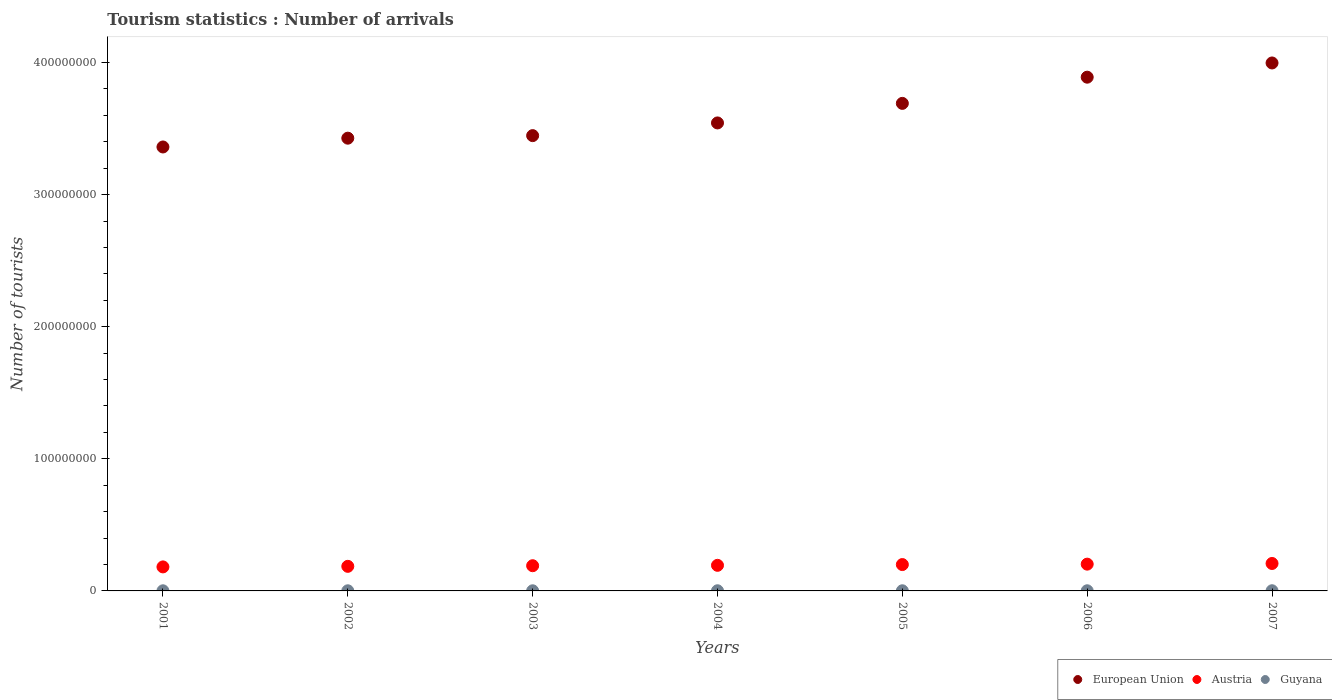What is the number of tourist arrivals in European Union in 2003?
Offer a terse response. 3.45e+08. Across all years, what is the maximum number of tourist arrivals in Guyana?
Keep it short and to the point. 1.34e+05. Across all years, what is the minimum number of tourist arrivals in Guyana?
Offer a very short reply. 9.90e+04. In which year was the number of tourist arrivals in European Union maximum?
Make the answer very short. 2007. What is the total number of tourist arrivals in Guyana in the graph?
Make the answer very short. 7.90e+05. What is the difference between the number of tourist arrivals in European Union in 2002 and that in 2005?
Make the answer very short. -2.63e+07. What is the difference between the number of tourist arrivals in Guyana in 2004 and the number of tourist arrivals in European Union in 2003?
Ensure brevity in your answer.  -3.45e+08. What is the average number of tourist arrivals in Guyana per year?
Keep it short and to the point. 1.13e+05. In the year 2004, what is the difference between the number of tourist arrivals in European Union and number of tourist arrivals in Guyana?
Offer a very short reply. 3.54e+08. What is the ratio of the number of tourist arrivals in Austria in 2002 to that in 2003?
Make the answer very short. 0.98. What is the difference between the highest and the second highest number of tourist arrivals in Austria?
Give a very brief answer. 5.04e+05. What is the difference between the highest and the lowest number of tourist arrivals in Guyana?
Make the answer very short. 3.50e+04. Is the sum of the number of tourist arrivals in European Union in 2001 and 2004 greater than the maximum number of tourist arrivals in Austria across all years?
Ensure brevity in your answer.  Yes. Does the number of tourist arrivals in European Union monotonically increase over the years?
Provide a succinct answer. Yes. Is the number of tourist arrivals in Austria strictly greater than the number of tourist arrivals in Guyana over the years?
Make the answer very short. Yes. Is the number of tourist arrivals in Austria strictly less than the number of tourist arrivals in Guyana over the years?
Your response must be concise. No. How many dotlines are there?
Ensure brevity in your answer.  3. How many years are there in the graph?
Offer a terse response. 7. Are the values on the major ticks of Y-axis written in scientific E-notation?
Give a very brief answer. No. Does the graph contain grids?
Offer a terse response. No. Where does the legend appear in the graph?
Your response must be concise. Bottom right. How are the legend labels stacked?
Your answer should be very brief. Horizontal. What is the title of the graph?
Give a very brief answer. Tourism statistics : Number of arrivals. Does "Bangladesh" appear as one of the legend labels in the graph?
Your response must be concise. No. What is the label or title of the Y-axis?
Offer a terse response. Number of tourists. What is the Number of tourists in European Union in 2001?
Provide a short and direct response. 3.36e+08. What is the Number of tourists of Austria in 2001?
Your answer should be compact. 1.82e+07. What is the Number of tourists in Guyana in 2001?
Provide a succinct answer. 9.90e+04. What is the Number of tourists of European Union in 2002?
Your response must be concise. 3.43e+08. What is the Number of tourists in Austria in 2002?
Ensure brevity in your answer.  1.86e+07. What is the Number of tourists in Guyana in 2002?
Make the answer very short. 1.04e+05. What is the Number of tourists of European Union in 2003?
Your answer should be compact. 3.45e+08. What is the Number of tourists of Austria in 2003?
Your response must be concise. 1.91e+07. What is the Number of tourists in Guyana in 2003?
Provide a short and direct response. 1.01e+05. What is the Number of tourists in European Union in 2004?
Keep it short and to the point. 3.54e+08. What is the Number of tourists of Austria in 2004?
Offer a very short reply. 1.94e+07. What is the Number of tourists of Guyana in 2004?
Your response must be concise. 1.22e+05. What is the Number of tourists of European Union in 2005?
Provide a succinct answer. 3.69e+08. What is the Number of tourists of Austria in 2005?
Offer a terse response. 2.00e+07. What is the Number of tourists of Guyana in 2005?
Provide a succinct answer. 1.17e+05. What is the Number of tourists of European Union in 2006?
Provide a succinct answer. 3.89e+08. What is the Number of tourists of Austria in 2006?
Your answer should be compact. 2.03e+07. What is the Number of tourists in Guyana in 2006?
Offer a terse response. 1.13e+05. What is the Number of tourists of European Union in 2007?
Give a very brief answer. 4.00e+08. What is the Number of tourists in Austria in 2007?
Offer a very short reply. 2.08e+07. What is the Number of tourists in Guyana in 2007?
Your answer should be compact. 1.34e+05. Across all years, what is the maximum Number of tourists of European Union?
Offer a very short reply. 4.00e+08. Across all years, what is the maximum Number of tourists of Austria?
Your answer should be very brief. 2.08e+07. Across all years, what is the maximum Number of tourists of Guyana?
Offer a very short reply. 1.34e+05. Across all years, what is the minimum Number of tourists of European Union?
Make the answer very short. 3.36e+08. Across all years, what is the minimum Number of tourists in Austria?
Ensure brevity in your answer.  1.82e+07. Across all years, what is the minimum Number of tourists of Guyana?
Provide a succinct answer. 9.90e+04. What is the total Number of tourists of European Union in the graph?
Provide a succinct answer. 2.54e+09. What is the total Number of tourists in Austria in the graph?
Give a very brief answer. 1.36e+08. What is the total Number of tourists of Guyana in the graph?
Offer a terse response. 7.90e+05. What is the difference between the Number of tourists of European Union in 2001 and that in 2002?
Offer a very short reply. -6.65e+06. What is the difference between the Number of tourists in Austria in 2001 and that in 2002?
Make the answer very short. -4.31e+05. What is the difference between the Number of tourists of Guyana in 2001 and that in 2002?
Your answer should be very brief. -5000. What is the difference between the Number of tourists of European Union in 2001 and that in 2003?
Offer a terse response. -8.59e+06. What is the difference between the Number of tourists of Austria in 2001 and that in 2003?
Your answer should be very brief. -8.98e+05. What is the difference between the Number of tourists in Guyana in 2001 and that in 2003?
Offer a very short reply. -2000. What is the difference between the Number of tourists of European Union in 2001 and that in 2004?
Your answer should be compact. -1.82e+07. What is the difference between the Number of tourists of Austria in 2001 and that in 2004?
Offer a terse response. -1.19e+06. What is the difference between the Number of tourists in Guyana in 2001 and that in 2004?
Provide a short and direct response. -2.30e+04. What is the difference between the Number of tourists in European Union in 2001 and that in 2005?
Your response must be concise. -3.30e+07. What is the difference between the Number of tourists of Austria in 2001 and that in 2005?
Offer a very short reply. -1.77e+06. What is the difference between the Number of tourists in Guyana in 2001 and that in 2005?
Provide a short and direct response. -1.80e+04. What is the difference between the Number of tourists in European Union in 2001 and that in 2006?
Provide a succinct answer. -5.28e+07. What is the difference between the Number of tourists in Austria in 2001 and that in 2006?
Your response must be concise. -2.09e+06. What is the difference between the Number of tourists of Guyana in 2001 and that in 2006?
Give a very brief answer. -1.40e+04. What is the difference between the Number of tourists of European Union in 2001 and that in 2007?
Your response must be concise. -6.36e+07. What is the difference between the Number of tourists in Austria in 2001 and that in 2007?
Give a very brief answer. -2.59e+06. What is the difference between the Number of tourists of Guyana in 2001 and that in 2007?
Give a very brief answer. -3.50e+04. What is the difference between the Number of tourists in European Union in 2002 and that in 2003?
Your answer should be very brief. -1.93e+06. What is the difference between the Number of tourists of Austria in 2002 and that in 2003?
Make the answer very short. -4.67e+05. What is the difference between the Number of tourists of Guyana in 2002 and that in 2003?
Make the answer very short. 3000. What is the difference between the Number of tourists in European Union in 2002 and that in 2004?
Keep it short and to the point. -1.15e+07. What is the difference between the Number of tourists of Austria in 2002 and that in 2004?
Provide a succinct answer. -7.63e+05. What is the difference between the Number of tourists of Guyana in 2002 and that in 2004?
Keep it short and to the point. -1.80e+04. What is the difference between the Number of tourists in European Union in 2002 and that in 2005?
Offer a terse response. -2.63e+07. What is the difference between the Number of tourists of Austria in 2002 and that in 2005?
Ensure brevity in your answer.  -1.34e+06. What is the difference between the Number of tourists of Guyana in 2002 and that in 2005?
Your answer should be very brief. -1.30e+04. What is the difference between the Number of tourists of European Union in 2002 and that in 2006?
Offer a terse response. -4.62e+07. What is the difference between the Number of tourists in Austria in 2002 and that in 2006?
Provide a short and direct response. -1.66e+06. What is the difference between the Number of tourists in Guyana in 2002 and that in 2006?
Make the answer very short. -9000. What is the difference between the Number of tourists of European Union in 2002 and that in 2007?
Offer a very short reply. -5.69e+07. What is the difference between the Number of tourists in Austria in 2002 and that in 2007?
Provide a succinct answer. -2.16e+06. What is the difference between the Number of tourists in Guyana in 2002 and that in 2007?
Keep it short and to the point. -3.00e+04. What is the difference between the Number of tourists in European Union in 2003 and that in 2004?
Offer a very short reply. -9.61e+06. What is the difference between the Number of tourists of Austria in 2003 and that in 2004?
Offer a very short reply. -2.96e+05. What is the difference between the Number of tourists in Guyana in 2003 and that in 2004?
Ensure brevity in your answer.  -2.10e+04. What is the difference between the Number of tourists in European Union in 2003 and that in 2005?
Your answer should be compact. -2.44e+07. What is the difference between the Number of tourists of Austria in 2003 and that in 2005?
Offer a very short reply. -8.74e+05. What is the difference between the Number of tourists of Guyana in 2003 and that in 2005?
Provide a succinct answer. -1.60e+04. What is the difference between the Number of tourists of European Union in 2003 and that in 2006?
Make the answer very short. -4.42e+07. What is the difference between the Number of tourists in Austria in 2003 and that in 2006?
Provide a succinct answer. -1.19e+06. What is the difference between the Number of tourists in Guyana in 2003 and that in 2006?
Your answer should be compact. -1.20e+04. What is the difference between the Number of tourists in European Union in 2003 and that in 2007?
Offer a terse response. -5.50e+07. What is the difference between the Number of tourists in Austria in 2003 and that in 2007?
Keep it short and to the point. -1.70e+06. What is the difference between the Number of tourists in Guyana in 2003 and that in 2007?
Your response must be concise. -3.30e+04. What is the difference between the Number of tourists of European Union in 2004 and that in 2005?
Make the answer very short. -1.48e+07. What is the difference between the Number of tourists of Austria in 2004 and that in 2005?
Your answer should be very brief. -5.78e+05. What is the difference between the Number of tourists of Guyana in 2004 and that in 2005?
Offer a terse response. 5000. What is the difference between the Number of tourists in European Union in 2004 and that in 2006?
Offer a very short reply. -3.46e+07. What is the difference between the Number of tourists in Austria in 2004 and that in 2006?
Your answer should be compact. -8.95e+05. What is the difference between the Number of tourists in Guyana in 2004 and that in 2006?
Ensure brevity in your answer.  9000. What is the difference between the Number of tourists of European Union in 2004 and that in 2007?
Make the answer very short. -4.54e+07. What is the difference between the Number of tourists in Austria in 2004 and that in 2007?
Provide a succinct answer. -1.40e+06. What is the difference between the Number of tourists in Guyana in 2004 and that in 2007?
Your answer should be compact. -1.20e+04. What is the difference between the Number of tourists in European Union in 2005 and that in 2006?
Make the answer very short. -1.98e+07. What is the difference between the Number of tourists in Austria in 2005 and that in 2006?
Provide a short and direct response. -3.17e+05. What is the difference between the Number of tourists in Guyana in 2005 and that in 2006?
Offer a terse response. 4000. What is the difference between the Number of tourists in European Union in 2005 and that in 2007?
Make the answer very short. -3.06e+07. What is the difference between the Number of tourists of Austria in 2005 and that in 2007?
Your answer should be very brief. -8.21e+05. What is the difference between the Number of tourists in Guyana in 2005 and that in 2007?
Your answer should be compact. -1.70e+04. What is the difference between the Number of tourists in European Union in 2006 and that in 2007?
Ensure brevity in your answer.  -1.08e+07. What is the difference between the Number of tourists of Austria in 2006 and that in 2007?
Your answer should be very brief. -5.04e+05. What is the difference between the Number of tourists in Guyana in 2006 and that in 2007?
Offer a very short reply. -2.10e+04. What is the difference between the Number of tourists in European Union in 2001 and the Number of tourists in Austria in 2002?
Keep it short and to the point. 3.17e+08. What is the difference between the Number of tourists in European Union in 2001 and the Number of tourists in Guyana in 2002?
Your answer should be compact. 3.36e+08. What is the difference between the Number of tourists of Austria in 2001 and the Number of tourists of Guyana in 2002?
Make the answer very short. 1.81e+07. What is the difference between the Number of tourists of European Union in 2001 and the Number of tourists of Austria in 2003?
Give a very brief answer. 3.17e+08. What is the difference between the Number of tourists in European Union in 2001 and the Number of tourists in Guyana in 2003?
Your response must be concise. 3.36e+08. What is the difference between the Number of tourists of Austria in 2001 and the Number of tourists of Guyana in 2003?
Ensure brevity in your answer.  1.81e+07. What is the difference between the Number of tourists in European Union in 2001 and the Number of tourists in Austria in 2004?
Ensure brevity in your answer.  3.17e+08. What is the difference between the Number of tourists in European Union in 2001 and the Number of tourists in Guyana in 2004?
Make the answer very short. 3.36e+08. What is the difference between the Number of tourists in Austria in 2001 and the Number of tourists in Guyana in 2004?
Offer a very short reply. 1.81e+07. What is the difference between the Number of tourists of European Union in 2001 and the Number of tourists of Austria in 2005?
Ensure brevity in your answer.  3.16e+08. What is the difference between the Number of tourists of European Union in 2001 and the Number of tourists of Guyana in 2005?
Provide a short and direct response. 3.36e+08. What is the difference between the Number of tourists of Austria in 2001 and the Number of tourists of Guyana in 2005?
Offer a very short reply. 1.81e+07. What is the difference between the Number of tourists in European Union in 2001 and the Number of tourists in Austria in 2006?
Offer a very short reply. 3.16e+08. What is the difference between the Number of tourists in European Union in 2001 and the Number of tourists in Guyana in 2006?
Offer a terse response. 3.36e+08. What is the difference between the Number of tourists in Austria in 2001 and the Number of tourists in Guyana in 2006?
Ensure brevity in your answer.  1.81e+07. What is the difference between the Number of tourists of European Union in 2001 and the Number of tourists of Austria in 2007?
Your answer should be compact. 3.15e+08. What is the difference between the Number of tourists in European Union in 2001 and the Number of tourists in Guyana in 2007?
Offer a terse response. 3.36e+08. What is the difference between the Number of tourists of Austria in 2001 and the Number of tourists of Guyana in 2007?
Provide a short and direct response. 1.80e+07. What is the difference between the Number of tourists of European Union in 2002 and the Number of tourists of Austria in 2003?
Keep it short and to the point. 3.24e+08. What is the difference between the Number of tourists in European Union in 2002 and the Number of tourists in Guyana in 2003?
Ensure brevity in your answer.  3.43e+08. What is the difference between the Number of tourists of Austria in 2002 and the Number of tourists of Guyana in 2003?
Provide a short and direct response. 1.85e+07. What is the difference between the Number of tourists of European Union in 2002 and the Number of tourists of Austria in 2004?
Offer a very short reply. 3.23e+08. What is the difference between the Number of tourists of European Union in 2002 and the Number of tourists of Guyana in 2004?
Provide a short and direct response. 3.43e+08. What is the difference between the Number of tourists of Austria in 2002 and the Number of tourists of Guyana in 2004?
Your answer should be compact. 1.85e+07. What is the difference between the Number of tourists of European Union in 2002 and the Number of tourists of Austria in 2005?
Offer a terse response. 3.23e+08. What is the difference between the Number of tourists of European Union in 2002 and the Number of tourists of Guyana in 2005?
Your answer should be very brief. 3.43e+08. What is the difference between the Number of tourists in Austria in 2002 and the Number of tourists in Guyana in 2005?
Your answer should be compact. 1.85e+07. What is the difference between the Number of tourists in European Union in 2002 and the Number of tourists in Austria in 2006?
Make the answer very short. 3.22e+08. What is the difference between the Number of tourists of European Union in 2002 and the Number of tourists of Guyana in 2006?
Your answer should be compact. 3.43e+08. What is the difference between the Number of tourists in Austria in 2002 and the Number of tourists in Guyana in 2006?
Keep it short and to the point. 1.85e+07. What is the difference between the Number of tourists in European Union in 2002 and the Number of tourists in Austria in 2007?
Provide a succinct answer. 3.22e+08. What is the difference between the Number of tourists of European Union in 2002 and the Number of tourists of Guyana in 2007?
Your answer should be compact. 3.43e+08. What is the difference between the Number of tourists in Austria in 2002 and the Number of tourists in Guyana in 2007?
Your answer should be very brief. 1.85e+07. What is the difference between the Number of tourists in European Union in 2003 and the Number of tourists in Austria in 2004?
Provide a succinct answer. 3.25e+08. What is the difference between the Number of tourists in European Union in 2003 and the Number of tourists in Guyana in 2004?
Keep it short and to the point. 3.45e+08. What is the difference between the Number of tourists in Austria in 2003 and the Number of tourists in Guyana in 2004?
Keep it short and to the point. 1.90e+07. What is the difference between the Number of tourists of European Union in 2003 and the Number of tourists of Austria in 2005?
Your answer should be very brief. 3.25e+08. What is the difference between the Number of tourists of European Union in 2003 and the Number of tourists of Guyana in 2005?
Give a very brief answer. 3.45e+08. What is the difference between the Number of tourists in Austria in 2003 and the Number of tourists in Guyana in 2005?
Provide a short and direct response. 1.90e+07. What is the difference between the Number of tourists in European Union in 2003 and the Number of tourists in Austria in 2006?
Your response must be concise. 3.24e+08. What is the difference between the Number of tourists of European Union in 2003 and the Number of tourists of Guyana in 2006?
Make the answer very short. 3.45e+08. What is the difference between the Number of tourists of Austria in 2003 and the Number of tourists of Guyana in 2006?
Your answer should be very brief. 1.90e+07. What is the difference between the Number of tourists in European Union in 2003 and the Number of tourists in Austria in 2007?
Ensure brevity in your answer.  3.24e+08. What is the difference between the Number of tourists of European Union in 2003 and the Number of tourists of Guyana in 2007?
Your answer should be very brief. 3.45e+08. What is the difference between the Number of tourists of Austria in 2003 and the Number of tourists of Guyana in 2007?
Offer a terse response. 1.89e+07. What is the difference between the Number of tourists of European Union in 2004 and the Number of tourists of Austria in 2005?
Give a very brief answer. 3.34e+08. What is the difference between the Number of tourists in European Union in 2004 and the Number of tourists in Guyana in 2005?
Offer a terse response. 3.54e+08. What is the difference between the Number of tourists of Austria in 2004 and the Number of tourists of Guyana in 2005?
Keep it short and to the point. 1.93e+07. What is the difference between the Number of tourists in European Union in 2004 and the Number of tourists in Austria in 2006?
Give a very brief answer. 3.34e+08. What is the difference between the Number of tourists of European Union in 2004 and the Number of tourists of Guyana in 2006?
Provide a succinct answer. 3.54e+08. What is the difference between the Number of tourists of Austria in 2004 and the Number of tourists of Guyana in 2006?
Ensure brevity in your answer.  1.93e+07. What is the difference between the Number of tourists in European Union in 2004 and the Number of tourists in Austria in 2007?
Offer a very short reply. 3.33e+08. What is the difference between the Number of tourists in European Union in 2004 and the Number of tourists in Guyana in 2007?
Your answer should be very brief. 3.54e+08. What is the difference between the Number of tourists in Austria in 2004 and the Number of tourists in Guyana in 2007?
Offer a terse response. 1.92e+07. What is the difference between the Number of tourists in European Union in 2005 and the Number of tourists in Austria in 2006?
Your answer should be very brief. 3.49e+08. What is the difference between the Number of tourists in European Union in 2005 and the Number of tourists in Guyana in 2006?
Ensure brevity in your answer.  3.69e+08. What is the difference between the Number of tourists of Austria in 2005 and the Number of tourists of Guyana in 2006?
Keep it short and to the point. 1.98e+07. What is the difference between the Number of tourists of European Union in 2005 and the Number of tourists of Austria in 2007?
Provide a short and direct response. 3.48e+08. What is the difference between the Number of tourists of European Union in 2005 and the Number of tourists of Guyana in 2007?
Your answer should be compact. 3.69e+08. What is the difference between the Number of tourists in Austria in 2005 and the Number of tourists in Guyana in 2007?
Your answer should be very brief. 1.98e+07. What is the difference between the Number of tourists in European Union in 2006 and the Number of tourists in Austria in 2007?
Your response must be concise. 3.68e+08. What is the difference between the Number of tourists in European Union in 2006 and the Number of tourists in Guyana in 2007?
Offer a very short reply. 3.89e+08. What is the difference between the Number of tourists in Austria in 2006 and the Number of tourists in Guyana in 2007?
Offer a very short reply. 2.01e+07. What is the average Number of tourists in European Union per year?
Make the answer very short. 3.62e+08. What is the average Number of tourists in Austria per year?
Make the answer very short. 1.95e+07. What is the average Number of tourists of Guyana per year?
Make the answer very short. 1.13e+05. In the year 2001, what is the difference between the Number of tourists of European Union and Number of tourists of Austria?
Ensure brevity in your answer.  3.18e+08. In the year 2001, what is the difference between the Number of tourists in European Union and Number of tourists in Guyana?
Offer a very short reply. 3.36e+08. In the year 2001, what is the difference between the Number of tourists of Austria and Number of tourists of Guyana?
Your answer should be compact. 1.81e+07. In the year 2002, what is the difference between the Number of tourists in European Union and Number of tourists in Austria?
Provide a succinct answer. 3.24e+08. In the year 2002, what is the difference between the Number of tourists in European Union and Number of tourists in Guyana?
Give a very brief answer. 3.43e+08. In the year 2002, what is the difference between the Number of tourists in Austria and Number of tourists in Guyana?
Your answer should be compact. 1.85e+07. In the year 2003, what is the difference between the Number of tourists in European Union and Number of tourists in Austria?
Your response must be concise. 3.26e+08. In the year 2003, what is the difference between the Number of tourists in European Union and Number of tourists in Guyana?
Your response must be concise. 3.45e+08. In the year 2003, what is the difference between the Number of tourists in Austria and Number of tourists in Guyana?
Provide a succinct answer. 1.90e+07. In the year 2004, what is the difference between the Number of tourists of European Union and Number of tourists of Austria?
Your answer should be very brief. 3.35e+08. In the year 2004, what is the difference between the Number of tourists in European Union and Number of tourists in Guyana?
Your answer should be very brief. 3.54e+08. In the year 2004, what is the difference between the Number of tourists of Austria and Number of tourists of Guyana?
Your answer should be compact. 1.93e+07. In the year 2005, what is the difference between the Number of tourists of European Union and Number of tourists of Austria?
Ensure brevity in your answer.  3.49e+08. In the year 2005, what is the difference between the Number of tourists in European Union and Number of tourists in Guyana?
Provide a short and direct response. 3.69e+08. In the year 2005, what is the difference between the Number of tourists in Austria and Number of tourists in Guyana?
Keep it short and to the point. 1.98e+07. In the year 2006, what is the difference between the Number of tourists in European Union and Number of tourists in Austria?
Keep it short and to the point. 3.69e+08. In the year 2006, what is the difference between the Number of tourists in European Union and Number of tourists in Guyana?
Offer a very short reply. 3.89e+08. In the year 2006, what is the difference between the Number of tourists in Austria and Number of tourists in Guyana?
Your response must be concise. 2.02e+07. In the year 2007, what is the difference between the Number of tourists of European Union and Number of tourists of Austria?
Offer a very short reply. 3.79e+08. In the year 2007, what is the difference between the Number of tourists of European Union and Number of tourists of Guyana?
Your answer should be very brief. 4.00e+08. In the year 2007, what is the difference between the Number of tourists of Austria and Number of tourists of Guyana?
Offer a terse response. 2.06e+07. What is the ratio of the Number of tourists in European Union in 2001 to that in 2002?
Keep it short and to the point. 0.98. What is the ratio of the Number of tourists of Austria in 2001 to that in 2002?
Offer a terse response. 0.98. What is the ratio of the Number of tourists of Guyana in 2001 to that in 2002?
Your response must be concise. 0.95. What is the ratio of the Number of tourists in European Union in 2001 to that in 2003?
Your response must be concise. 0.98. What is the ratio of the Number of tourists in Austria in 2001 to that in 2003?
Give a very brief answer. 0.95. What is the ratio of the Number of tourists of Guyana in 2001 to that in 2003?
Give a very brief answer. 0.98. What is the ratio of the Number of tourists of European Union in 2001 to that in 2004?
Offer a terse response. 0.95. What is the ratio of the Number of tourists of Austria in 2001 to that in 2004?
Give a very brief answer. 0.94. What is the ratio of the Number of tourists of Guyana in 2001 to that in 2004?
Your response must be concise. 0.81. What is the ratio of the Number of tourists of European Union in 2001 to that in 2005?
Offer a very short reply. 0.91. What is the ratio of the Number of tourists in Austria in 2001 to that in 2005?
Offer a very short reply. 0.91. What is the ratio of the Number of tourists of Guyana in 2001 to that in 2005?
Keep it short and to the point. 0.85. What is the ratio of the Number of tourists of European Union in 2001 to that in 2006?
Your answer should be very brief. 0.86. What is the ratio of the Number of tourists of Austria in 2001 to that in 2006?
Ensure brevity in your answer.  0.9. What is the ratio of the Number of tourists in Guyana in 2001 to that in 2006?
Offer a terse response. 0.88. What is the ratio of the Number of tourists in European Union in 2001 to that in 2007?
Provide a short and direct response. 0.84. What is the ratio of the Number of tourists in Austria in 2001 to that in 2007?
Offer a very short reply. 0.88. What is the ratio of the Number of tourists of Guyana in 2001 to that in 2007?
Your answer should be compact. 0.74. What is the ratio of the Number of tourists in Austria in 2002 to that in 2003?
Provide a short and direct response. 0.98. What is the ratio of the Number of tourists in Guyana in 2002 to that in 2003?
Your answer should be compact. 1.03. What is the ratio of the Number of tourists of European Union in 2002 to that in 2004?
Your response must be concise. 0.97. What is the ratio of the Number of tourists of Austria in 2002 to that in 2004?
Your answer should be compact. 0.96. What is the ratio of the Number of tourists of Guyana in 2002 to that in 2004?
Provide a succinct answer. 0.85. What is the ratio of the Number of tourists of European Union in 2002 to that in 2005?
Keep it short and to the point. 0.93. What is the ratio of the Number of tourists in Austria in 2002 to that in 2005?
Your answer should be compact. 0.93. What is the ratio of the Number of tourists in Guyana in 2002 to that in 2005?
Ensure brevity in your answer.  0.89. What is the ratio of the Number of tourists of European Union in 2002 to that in 2006?
Offer a terse response. 0.88. What is the ratio of the Number of tourists in Austria in 2002 to that in 2006?
Offer a terse response. 0.92. What is the ratio of the Number of tourists of Guyana in 2002 to that in 2006?
Provide a short and direct response. 0.92. What is the ratio of the Number of tourists in European Union in 2002 to that in 2007?
Provide a succinct answer. 0.86. What is the ratio of the Number of tourists in Austria in 2002 to that in 2007?
Ensure brevity in your answer.  0.9. What is the ratio of the Number of tourists of Guyana in 2002 to that in 2007?
Ensure brevity in your answer.  0.78. What is the ratio of the Number of tourists in European Union in 2003 to that in 2004?
Keep it short and to the point. 0.97. What is the ratio of the Number of tourists in Austria in 2003 to that in 2004?
Your answer should be compact. 0.98. What is the ratio of the Number of tourists of Guyana in 2003 to that in 2004?
Provide a short and direct response. 0.83. What is the ratio of the Number of tourists in European Union in 2003 to that in 2005?
Make the answer very short. 0.93. What is the ratio of the Number of tourists in Austria in 2003 to that in 2005?
Keep it short and to the point. 0.96. What is the ratio of the Number of tourists in Guyana in 2003 to that in 2005?
Make the answer very short. 0.86. What is the ratio of the Number of tourists of European Union in 2003 to that in 2006?
Give a very brief answer. 0.89. What is the ratio of the Number of tourists of Austria in 2003 to that in 2006?
Offer a very short reply. 0.94. What is the ratio of the Number of tourists of Guyana in 2003 to that in 2006?
Keep it short and to the point. 0.89. What is the ratio of the Number of tourists in European Union in 2003 to that in 2007?
Give a very brief answer. 0.86. What is the ratio of the Number of tourists in Austria in 2003 to that in 2007?
Keep it short and to the point. 0.92. What is the ratio of the Number of tourists in Guyana in 2003 to that in 2007?
Keep it short and to the point. 0.75. What is the ratio of the Number of tourists in European Union in 2004 to that in 2005?
Make the answer very short. 0.96. What is the ratio of the Number of tourists of Guyana in 2004 to that in 2005?
Keep it short and to the point. 1.04. What is the ratio of the Number of tourists of European Union in 2004 to that in 2006?
Your response must be concise. 0.91. What is the ratio of the Number of tourists in Austria in 2004 to that in 2006?
Keep it short and to the point. 0.96. What is the ratio of the Number of tourists of Guyana in 2004 to that in 2006?
Make the answer very short. 1.08. What is the ratio of the Number of tourists in European Union in 2004 to that in 2007?
Offer a very short reply. 0.89. What is the ratio of the Number of tourists of Austria in 2004 to that in 2007?
Your response must be concise. 0.93. What is the ratio of the Number of tourists of Guyana in 2004 to that in 2007?
Provide a short and direct response. 0.91. What is the ratio of the Number of tourists of European Union in 2005 to that in 2006?
Give a very brief answer. 0.95. What is the ratio of the Number of tourists in Austria in 2005 to that in 2006?
Provide a short and direct response. 0.98. What is the ratio of the Number of tourists in Guyana in 2005 to that in 2006?
Keep it short and to the point. 1.04. What is the ratio of the Number of tourists of European Union in 2005 to that in 2007?
Your answer should be very brief. 0.92. What is the ratio of the Number of tourists of Austria in 2005 to that in 2007?
Ensure brevity in your answer.  0.96. What is the ratio of the Number of tourists of Guyana in 2005 to that in 2007?
Keep it short and to the point. 0.87. What is the ratio of the Number of tourists in European Union in 2006 to that in 2007?
Give a very brief answer. 0.97. What is the ratio of the Number of tourists in Austria in 2006 to that in 2007?
Keep it short and to the point. 0.98. What is the ratio of the Number of tourists in Guyana in 2006 to that in 2007?
Offer a very short reply. 0.84. What is the difference between the highest and the second highest Number of tourists in European Union?
Ensure brevity in your answer.  1.08e+07. What is the difference between the highest and the second highest Number of tourists of Austria?
Make the answer very short. 5.04e+05. What is the difference between the highest and the second highest Number of tourists in Guyana?
Your answer should be compact. 1.20e+04. What is the difference between the highest and the lowest Number of tourists of European Union?
Provide a short and direct response. 6.36e+07. What is the difference between the highest and the lowest Number of tourists in Austria?
Your answer should be very brief. 2.59e+06. What is the difference between the highest and the lowest Number of tourists of Guyana?
Make the answer very short. 3.50e+04. 